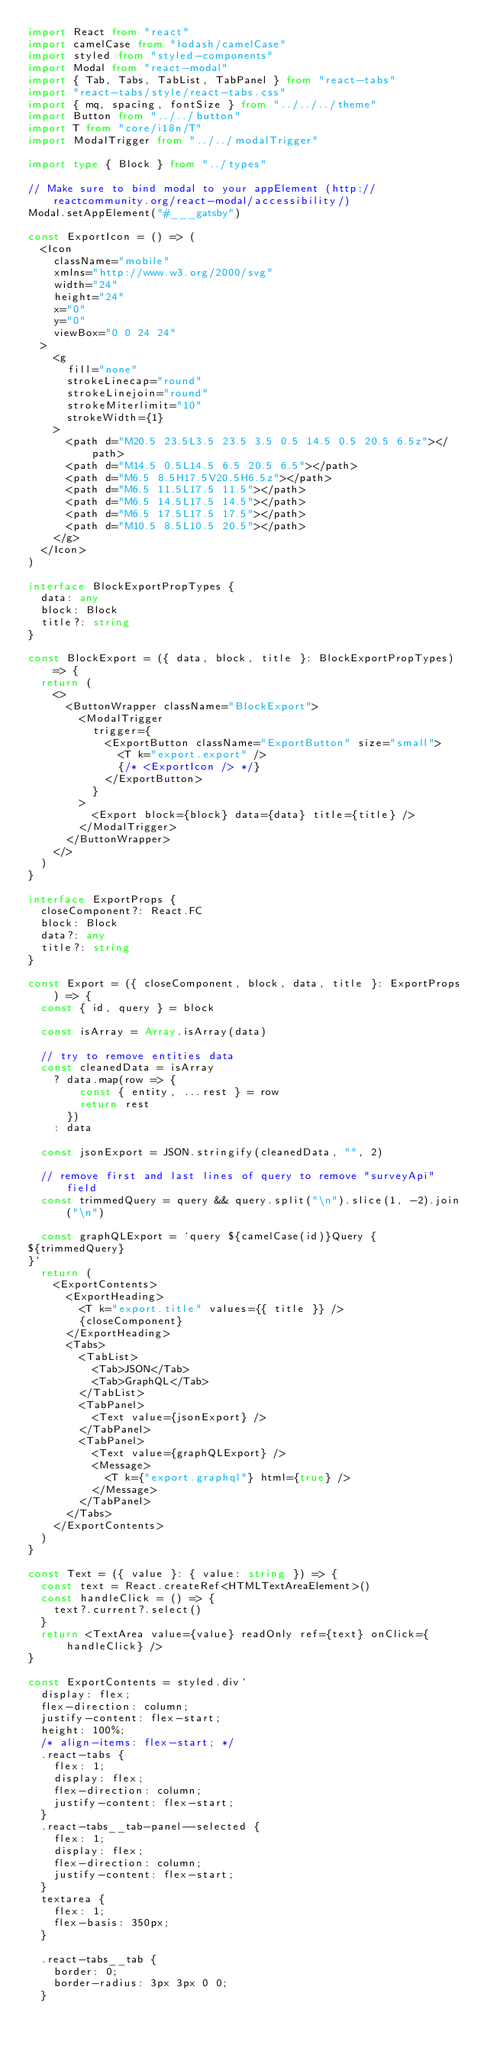<code> <loc_0><loc_0><loc_500><loc_500><_TypeScript_>import React from "react"
import camelCase from "lodash/camelCase"
import styled from "styled-components"
import Modal from "react-modal"
import { Tab, Tabs, TabList, TabPanel } from "react-tabs"
import "react-tabs/style/react-tabs.css"
import { mq, spacing, fontSize } from "../../../theme"
import Button from "../../button"
import T from "core/i18n/T"
import ModalTrigger from "../../modalTrigger"

import type { Block } from "../types"

// Make sure to bind modal to your appElement (http://reactcommunity.org/react-modal/accessibility/)
Modal.setAppElement("#___gatsby")

const ExportIcon = () => (
  <Icon
    className="mobile"
    xmlns="http://www.w3.org/2000/svg"
    width="24"
    height="24"
    x="0"
    y="0"
    viewBox="0 0 24 24"
  >
    <g
      fill="none"
      strokeLinecap="round"
      strokeLinejoin="round"
      strokeMiterlimit="10"
      strokeWidth={1}
    >
      <path d="M20.5 23.5L3.5 23.5 3.5 0.5 14.5 0.5 20.5 6.5z"></path>
      <path d="M14.5 0.5L14.5 6.5 20.5 6.5"></path>
      <path d="M6.5 8.5H17.5V20.5H6.5z"></path>
      <path d="M6.5 11.5L17.5 11.5"></path>
      <path d="M6.5 14.5L17.5 14.5"></path>
      <path d="M6.5 17.5L17.5 17.5"></path>
      <path d="M10.5 8.5L10.5 20.5"></path>
    </g>
  </Icon>
)

interface BlockExportPropTypes {
  data: any
  block: Block
  title?: string
}

const BlockExport = ({ data, block, title }: BlockExportPropTypes) => {
  return (
    <>
      <ButtonWrapper className="BlockExport">
        <ModalTrigger
          trigger={
            <ExportButton className="ExportButton" size="small">
              <T k="export.export" />
              {/* <ExportIcon /> */}
            </ExportButton>
          }
        >
          <Export block={block} data={data} title={title} />
        </ModalTrigger>
      </ButtonWrapper>
    </>
  )
}

interface ExportProps {
  closeComponent?: React.FC
  block: Block
  data?: any
  title?: string
}

const Export = ({ closeComponent, block, data, title }: ExportProps) => {
  const { id, query } = block

  const isArray = Array.isArray(data)

  // try to remove entities data
  const cleanedData = isArray
    ? data.map(row => {
        const { entity, ...rest } = row
        return rest
      })
    : data

  const jsonExport = JSON.stringify(cleanedData, "", 2)

  // remove first and last lines of query to remove "surveyApi" field
  const trimmedQuery = query && query.split("\n").slice(1, -2).join("\n")

  const graphQLExport = `query ${camelCase(id)}Query {
${trimmedQuery}
}`
  return (
    <ExportContents>
      <ExportHeading>
        <T k="export.title" values={{ title }} />
        {closeComponent}
      </ExportHeading>
      <Tabs>
        <TabList>
          <Tab>JSON</Tab>
          <Tab>GraphQL</Tab>
        </TabList>
        <TabPanel>
          <Text value={jsonExport} />
        </TabPanel>
        <TabPanel>
          <Text value={graphQLExport} />
          <Message>
            <T k={"export.graphql"} html={true} />
          </Message>
        </TabPanel>
      </Tabs>
    </ExportContents>
  )
}

const Text = ({ value }: { value: string }) => {
  const text = React.createRef<HTMLTextAreaElement>()
  const handleClick = () => {
    text?.current?.select()
  }
  return <TextArea value={value} readOnly ref={text} onClick={handleClick} />
}

const ExportContents = styled.div`
  display: flex;
  flex-direction: column;
  justify-content: flex-start;
  height: 100%;
  /* align-items: flex-start; */
  .react-tabs {
    flex: 1;
    display: flex;
    flex-direction: column;
    justify-content: flex-start;
  }
  .react-tabs__tab-panel--selected {
    flex: 1;
    display: flex;
    flex-direction: column;
    justify-content: flex-start;
  }
  textarea {
    flex: 1;
    flex-basis: 350px;
  }

  .react-tabs__tab {
    border: 0;
    border-radius: 3px 3px 0 0;
  }
</code> 